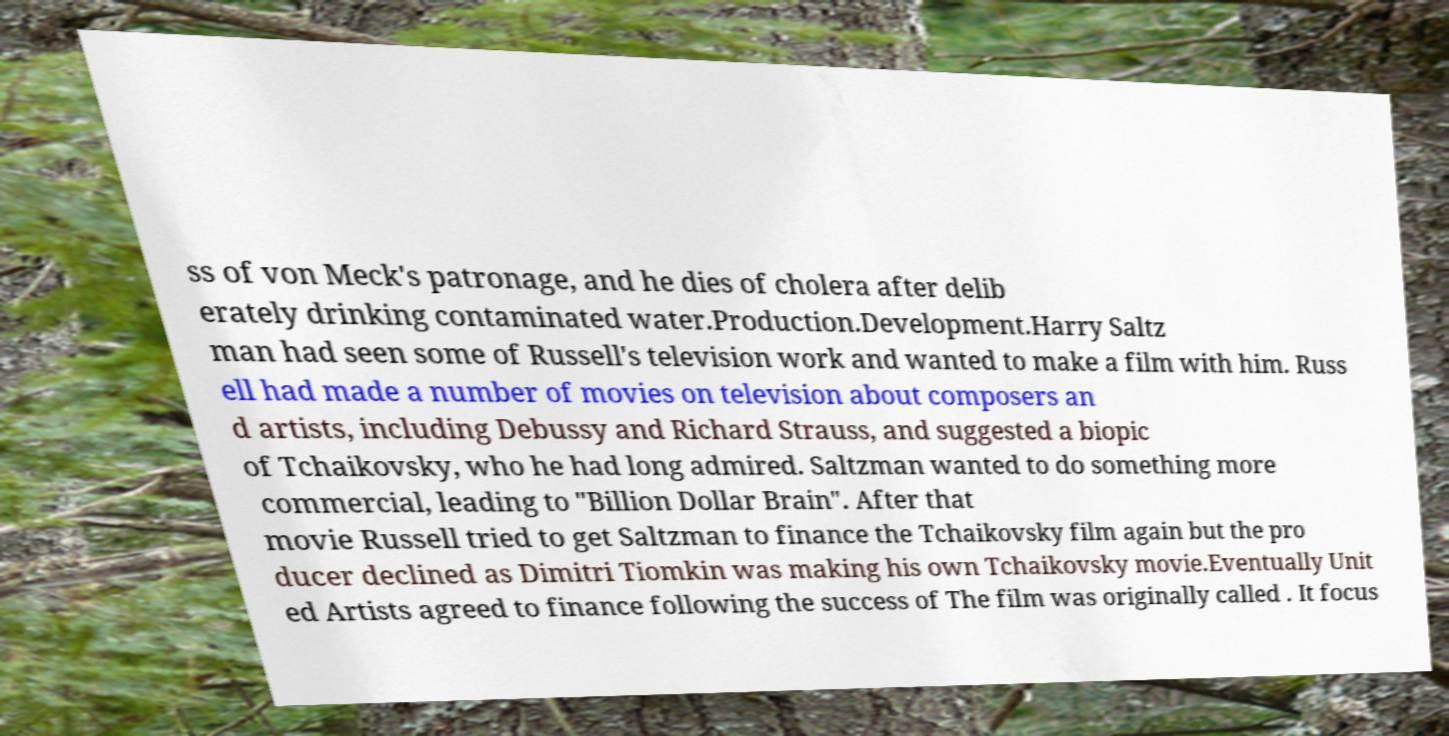I need the written content from this picture converted into text. Can you do that? ss of von Meck's patronage, and he dies of cholera after delib erately drinking contaminated water.Production.Development.Harry Saltz man had seen some of Russell's television work and wanted to make a film with him. Russ ell had made a number of movies on television about composers an d artists, including Debussy and Richard Strauss, and suggested a biopic of Tchaikovsky, who he had long admired. Saltzman wanted to do something more commercial, leading to "Billion Dollar Brain". After that movie Russell tried to get Saltzman to finance the Tchaikovsky film again but the pro ducer declined as Dimitri Tiomkin was making his own Tchaikovsky movie.Eventually Unit ed Artists agreed to finance following the success of The film was originally called . It focus 